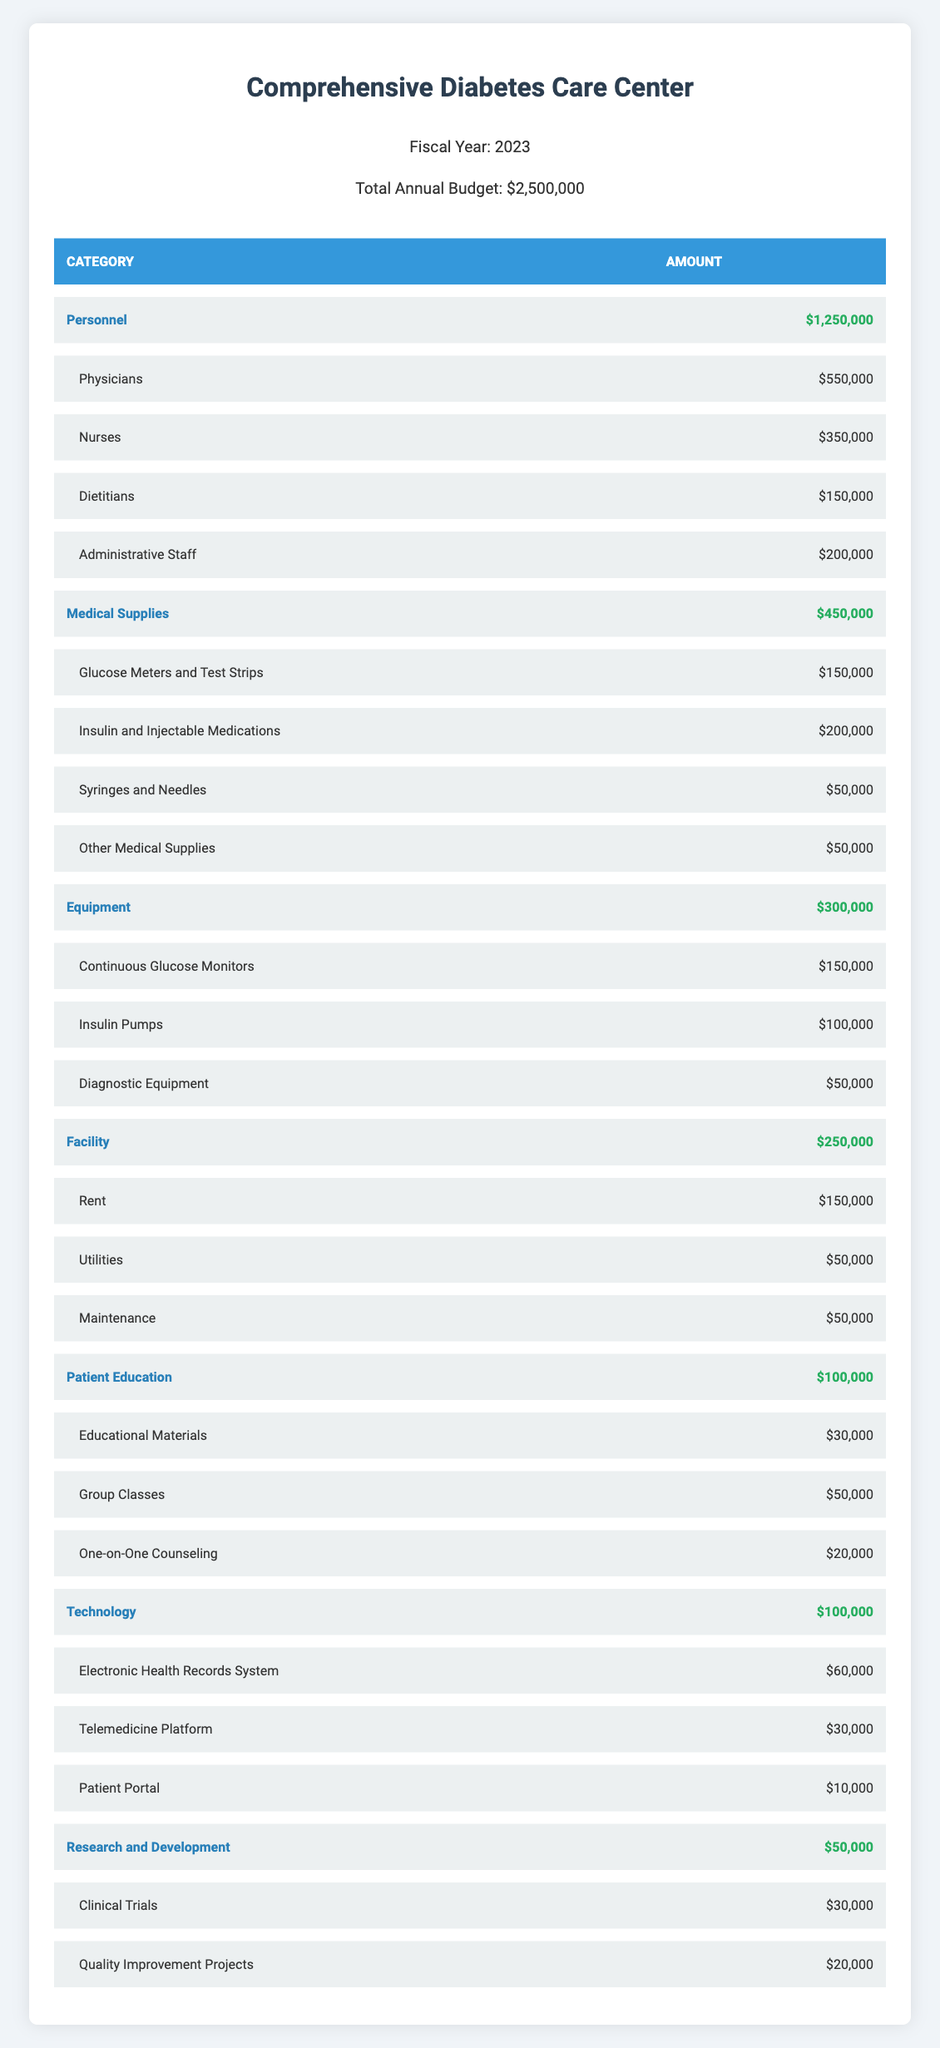What is the total budget allocated for Personnel? The category "Personnel" in the budget breakdown has an amount listed as $1,250,000. This value can be directly retrieved from the table without any calculations needed.
Answer: 1,250,000 How much is allocated for Medical Supplies in total? The total amount for the category "Medical Supplies" is provided as $450,000 in the budget breakdown. This is directly taken from the table under that specific category.
Answer: 450,000 Is the amount spent on Insulin and Injectable Medications greater than that for Continuous Glucose Monitors? The amount for Insulin and Injectable Medications is $200,000, which is greater than the $150,000 allocated for Continuous Glucose Monitors. Therefore, the statement is true.
Answer: Yes What is the total expenditure on Patient Education, Equipment, and Technology combined? The amounts for Patient Education ($100,000), Equipment ($300,000), and Technology ($100,000) need to be summed: 100,000 + 300,000 + 100,000 = 500,000. Therefore, the total expenditure for these categories combined is $500,000.
Answer: 500,000 Are the expenses for Administrative Staff less than the combined amount of the expenses for Nurses and Dietitians? Administrative Staff expenses are recorded as $200,000. The sum for Nurses ($350,000) and Dietitians ($150,000) is $500,000 (350,000 + 150,000). Since $200,000 is less than $500,000, the statement is true.
Answer: Yes How much more is spent on Glucose Meters and Test Strips compared to Syringes and Needles? The budget for Glucose Meters and Test Strips is $150,000, while for Syringes and Needles it is $50,000. The difference can be calculated as $150,000 - $50,000 = $100,000, showing that there is an excess of $100,000 spent.
Answer: 100,000 What proportion of the total annual budget is allocated to Research and Development? The amount allocated to Research and Development is $50,000. The total budget is $2,500,000, so the proportion can be calculated as $50,000 / $2,500,000 = 0.02, or 2%. This indicates that 2% of the total budget is dedicated to this category.
Answer: 2% Which category has the highest total allocation? By examining the budget breakdown, "Personnel" with $1,250,000 has the highest total allocation compared to other categories listed, such as Medical Supplies, which is $450,000.
Answer: Personnel How much do the total costs for Facility, Patient Education, and Research and Development together amount to? The costs for Facility ($250,000), Patient Education ($100,000), and Research and Development ($50,000) are summed together: 250,000 + 100,000 + 50,000 = 400,000. Thus, the total costs for these categories together amount to $400,000.
Answer: 400,000 